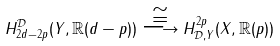Convert formula to latex. <formula><loc_0><loc_0><loc_500><loc_500>H _ { 2 d - 2 p } ^ { \mathcal { D } } ( Y , \mathbb { R } ( d - p ) ) \overset { \cong } { \longrightarrow } H ^ { 2 p } _ { \mathcal { D } , Y } ( X , \mathbb { R } ( p ) )</formula> 